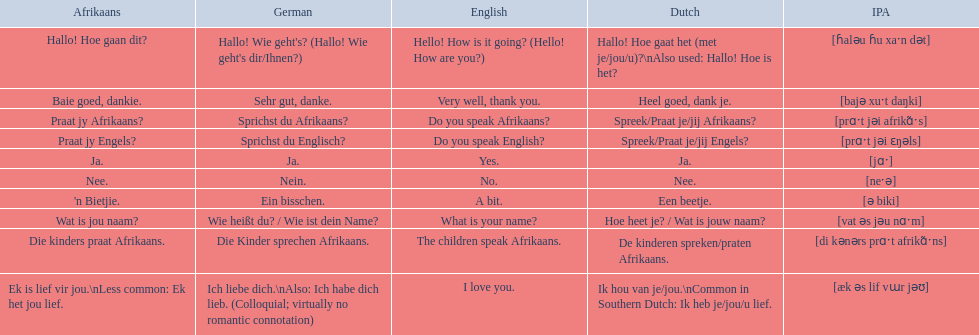What are the listed afrikaans phrases? Hallo! Hoe gaan dit?, Baie goed, dankie., Praat jy Afrikaans?, Praat jy Engels?, Ja., Nee., 'n Bietjie., Wat is jou naam?, Die kinders praat Afrikaans., Ek is lief vir jou.\nLess common: Ek het jou lief. Which is die kinders praat afrikaans? Die kinders praat Afrikaans. What is its german translation? Die Kinder sprechen Afrikaans. 